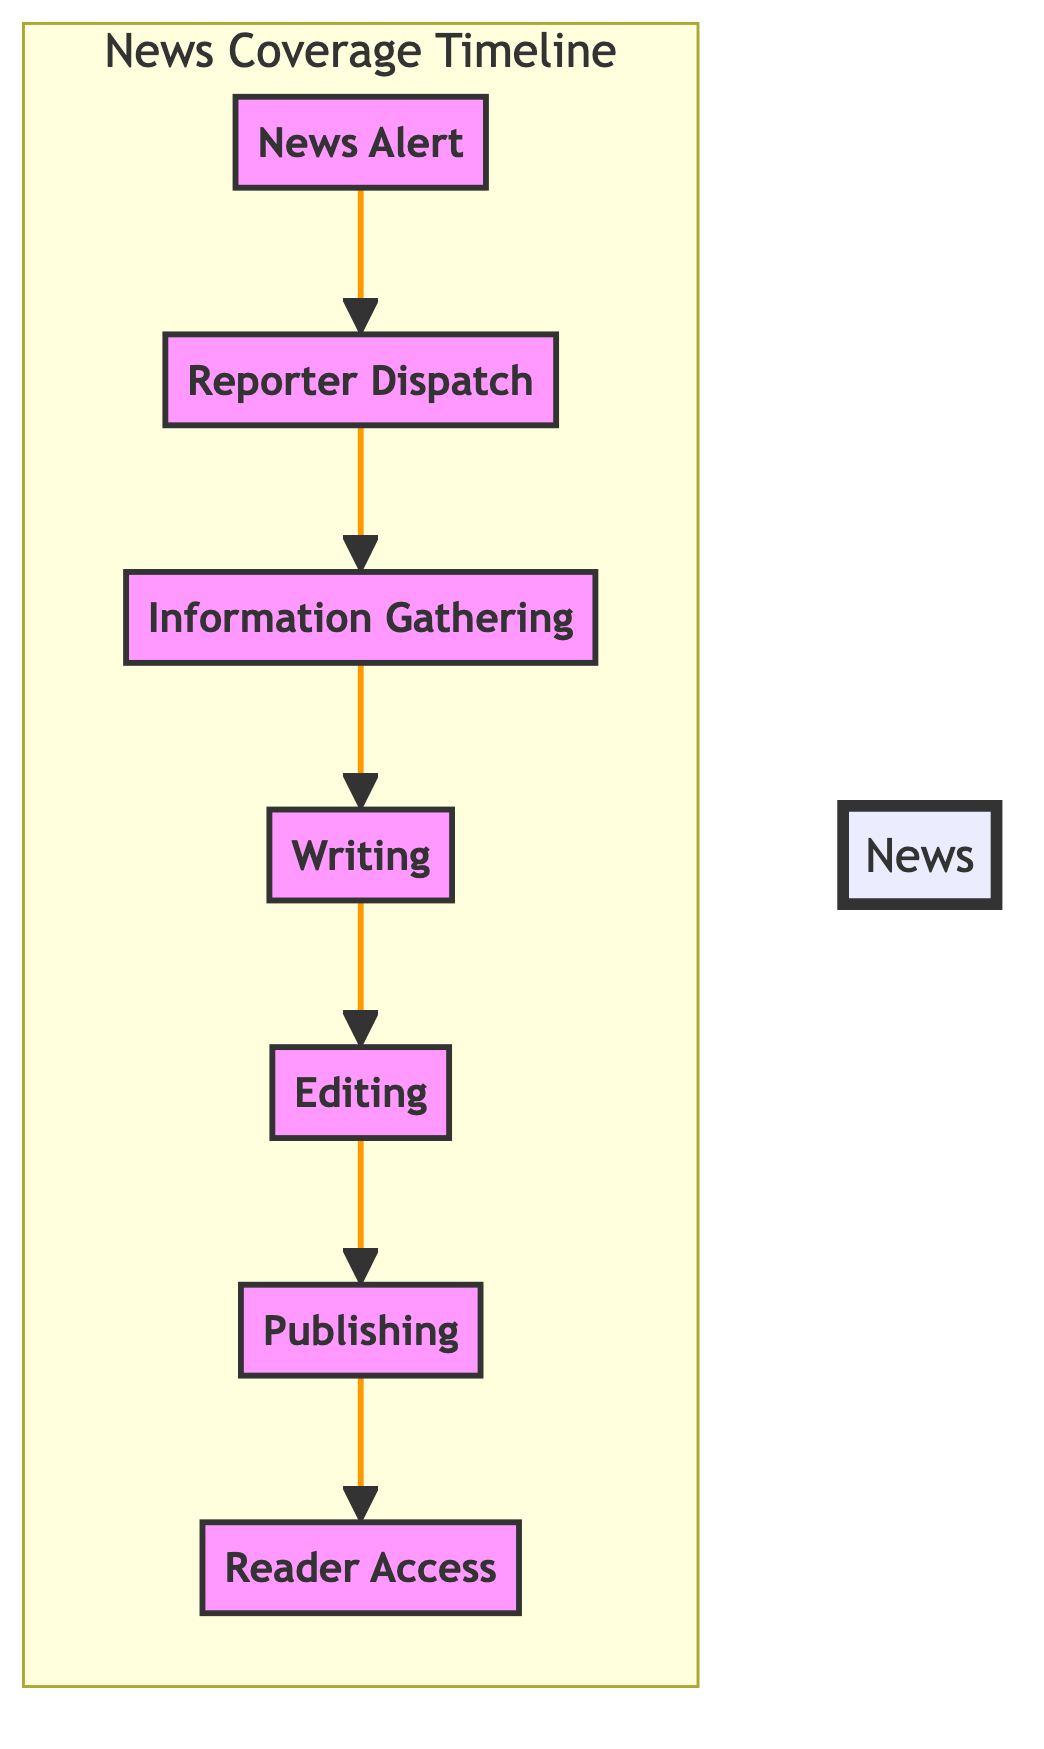What is the first step in the news coverage timeline? The first step, as indicated in the diagram, is "News Alert." It is represented at the bottom of the flow, showing that it initiates the news coverage process.
Answer: News Alert How many steps are there in the news coverage timeline? By counting the nodes represented in the diagram, there are seven distinct steps listed from "News Alert" to "Reader Access."
Answer: 7 What is the relationship between "Information Gathering" and "Writing"? "Information Gathering" directly precedes "Writing" in the flow, indicating that reporters and journalists use the gathered information to write the news story.
Answer: Directly precedes Which step follows "Editing"? In the sequence of the diagram, the step that follows "Editing" is "Publishing." This shows that after editing, the story is published.
Answer: Publishing What is the last step in the news coverage timeline? The last step in the timeline, as shown at the top of the diagram, is "Reader Access," indicating the point at which news is accessible to the public.
Answer: Reader Access How does "Reporter Dispatch" relate to "Information Gathering"? "Reporter Dispatch" must happen before "Information Gathering," as reporters are sent out to gather information on events after arriving on site.
Answer: Must happen before Identify the main purpose of the "Editing" step. The main purpose of "Editing" is to ensure the news story is reviewed for accuracy, clarity, grammar, and adherence to editorial standards.
Answer: Ensure accuracy What precedes the "Final Story," which is "Publishing," in the timeline? Before the "Final Story" is "Editing," which is necessary to refine and prepare the news piece for publication.
Answer: Editing Which news outlets are mentioned in association with the "Writing" step? The news outlets associated with the "Writing" step include The New York Times, The Guardian, and The Washington Post as examples of where reporters work.
Answer: The New York Times, The Guardian, The Washington Post 